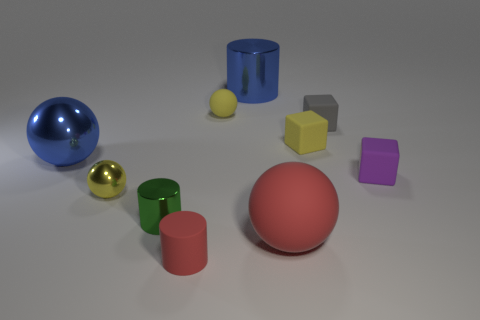Is the large rubber object the same color as the matte cylinder?
Offer a very short reply. Yes. There is a shiny thing that is the same color as the tiny matte sphere; what is its size?
Provide a short and direct response. Small. Are there any other things that are the same size as the green cylinder?
Provide a succinct answer. Yes. How many other objects are there of the same color as the large cylinder?
Provide a succinct answer. 1. The red cylinder has what size?
Your response must be concise. Small. There is a rubber sphere that is behind the tiny yellow block; is it the same color as the sphere to the left of the tiny yellow metal thing?
Offer a very short reply. No. What number of other things are there of the same material as the tiny gray object
Provide a short and direct response. 5. Is there a big red sphere?
Ensure brevity in your answer.  Yes. Is the red object to the left of the large red sphere made of the same material as the small gray thing?
Offer a terse response. Yes. What material is the red object that is the same shape as the tiny green shiny object?
Your response must be concise. Rubber. 